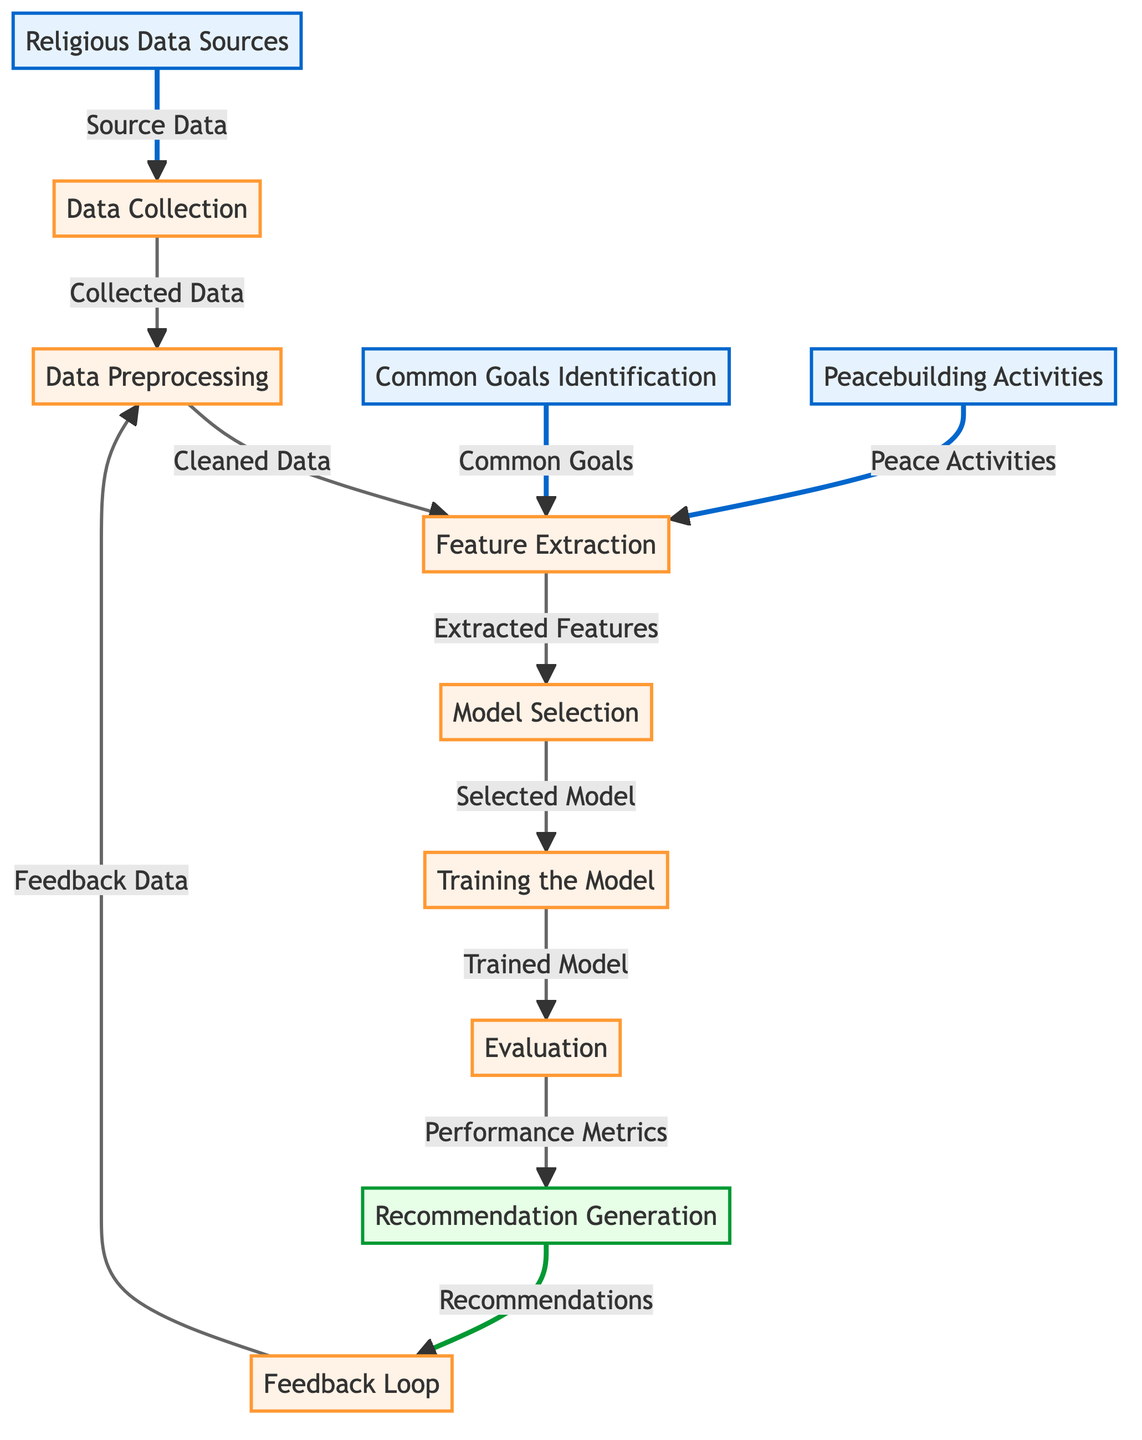What is the first node in the diagram? The first node in the diagram is "Religious Data Sources", which serves as the starting point for the data flow.
Answer: Religious Data Sources How many process nodes are present in the diagram? The diagram shows five process nodes: Data Collection, Data Preprocessing, Feature Extraction, Model Selection, and Training the Model.
Answer: Five What does the recommendation generation node output? The recommendation generation node outputs "Recommendations," indicating its role in providing suggested matches based on the processed data and model evaluations.
Answer: Recommendations Which node provides feedback data? The feedback loop node outputs feedback data into the data preprocessing node, helping to refine the recommendations produced by the model.
Answer: Feedback Loop What is the purpose of the common goals identification node? The common goals identification node provides "Common Goals," which are essential for feature extraction to align the interests of religious leaders in the collaboration process.
Answer: Common Goals What process follows the evaluation of the trained model? After evaluating the trained model, the next process is recommendation generation, where performance metrics are used to create recommendations.
Answer: Recommendation Generation How many nodes are connected to the feature extraction node? The feature extraction node is connected to three nodes: Data Preprocessing, Model Selection, and both Common Goals Identification and Peacebuilding Activities, indicating its integrative role.
Answer: Four What feedback does the feedback loop node incorporate? The feedback loop node incorporates "Feedback Data" gathered from previous recommendations, which is then used to improve the data preprocessing step for future cycles.
Answer: Feedback Data Which two source nodes contribute common goals to feature extraction? The two source nodes contributing common goals to feature extraction are "Common Goals Identification" and "Peacebuilding Activities," indicating the sources of alignment for collaboration.
Answer: Common Goals Identification, Peacebuilding Activities 